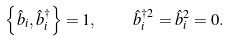Convert formula to latex. <formula><loc_0><loc_0><loc_500><loc_500>\left \{ \hat { b } _ { i } , \hat { b } ^ { \dagger } _ { i } \right \} = 1 , \quad \hat { b } ^ { \dagger 2 } _ { i } = \hat { b } ^ { 2 } _ { i } = 0 .</formula> 